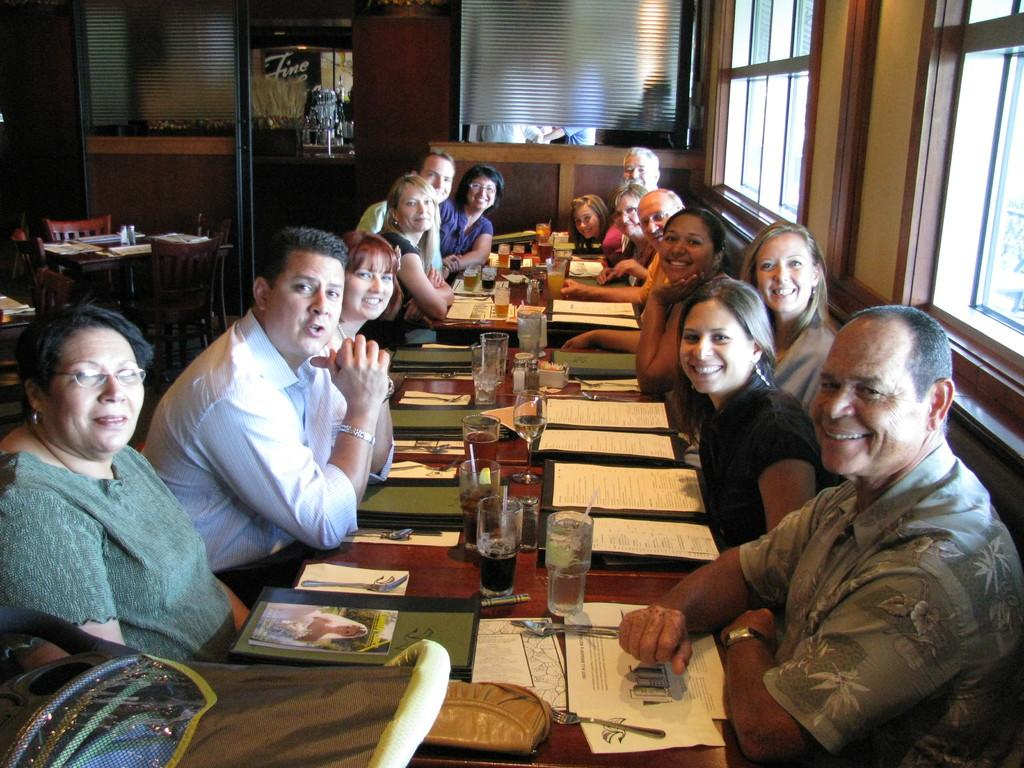What are the people in the image doing? The people in the image are sitting around the table. What objects can be seen on the table? There are glasses, spoons, forks, menu cards, and a bag on the table. What type of windows can be seen in the background of the image? There are glass windows in the background of the image. Can you see any jeans hanging on the glass windows in the image? There are no jeans visible in the image; only the people, table, and glass windows can be seen. Are there any frogs hopping around on the table in the image? There are no frogs present in the image; only the people, table, and various objects can be seen. 